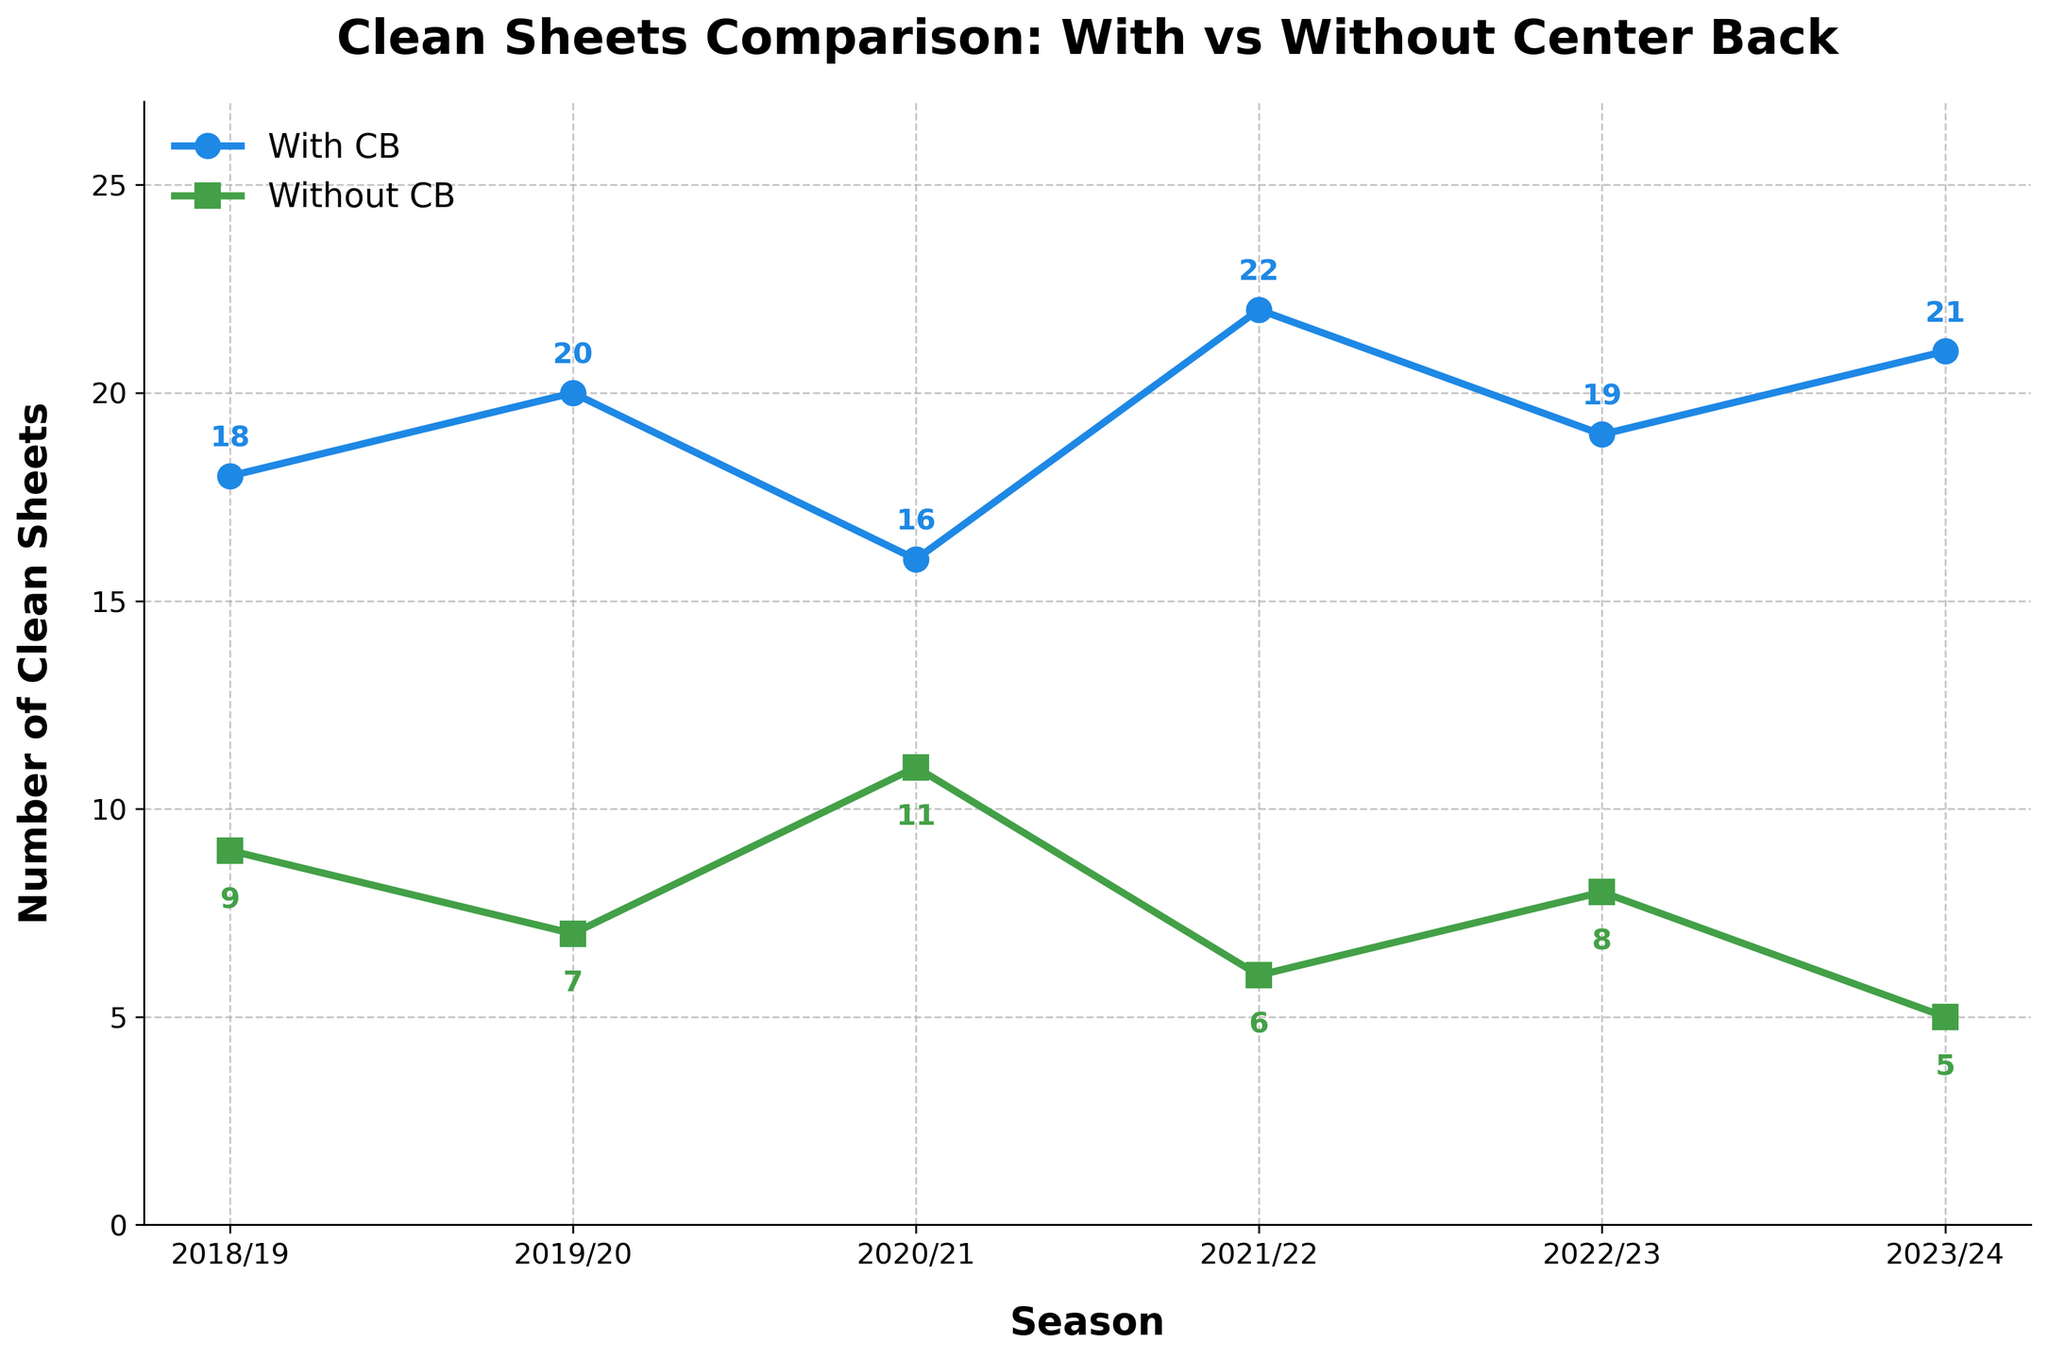What is the difference in the number of clean sheets with the center back and without the center back in the 2022/23 season? To find the difference, subtract the number of clean sheets without the CB (8) from the number of clean sheets with the CB (19). 19 - 8 = 11
Answer: 11 Which season had the highest number of clean sheets with the center back? By looking at the figure, identify the peak point in the line representing clean sheets with the CB. The highest value is 22 in the 2021/22 season.
Answer: 2021/22 What is the average number of clean sheets without the center back from 2018/19 to 2023/24? Sum the clean sheets without the CB for all seasons (9 + 7 + 11 + 6 + 8 + 5 = 46) and divide by the number of seasons (6). 46/6 = 7.67
Answer: 7.67 In which season was the difference between clean sheets with and without the center back the smallest? Calculate the differences for each season: 2018/19 (18-9=9), 2019/20 (20-7=13), 2020/21 (16-11=5), 2021/22 (22-6=16), 2022/23 (19-8=11), 2023/24 (21-5=16). The smallest difference is in the 2020/21 season with a difference of 5.
Answer: 2020/21 How many more clean sheets were there with the center back than without in the 2019/20 season? Subtract the number of clean sheets without the CB (7) from the number of clean sheets with the CB (20). 20 - 7 = 13
Answer: 13 What is the total number of clean sheets with the center back over all seasons? Sum the number of clean sheets with the CB for all seasons (18 + 20 + 16 + 22 + 19 + 21). 18 + 20 + 16 + 22 + 19 + 21 = 116
Answer: 116 Which line in the figure is represented by green markers? Identify the color that represents the line with clean sheets without the center back, which has green markers.
Answer: Clean Sheets without CB In which season was the difference in the number of clean sheets the greatest? Calculate the differences for each season and compare: 2018/19 (9), 2019/20 (13), 2020/21 (5), 2021/22 (16), 2022/23 (11), and 2023/24 (16). The greatest difference is in 2021/22 and 2023/24 at 16.
Answer: 2021/22 and 2023/24 What is the median number of clean sheets with the center back? List all values of clean sheets with the CB: 18, 20, 16, 22, 19, 21. The median is the average of the middle two values (20 and 19). (20 + 19) / 2 = 19.5
Answer: 19.5 